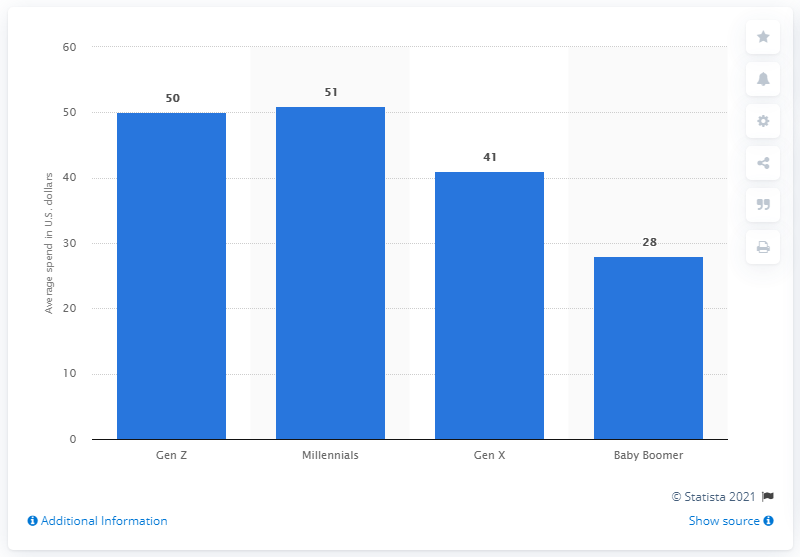How many dollars did Millennials plan to spend on their pets on average during the holiday season? Based on the bar chart, Millennials planned to spend an average of $51 on their pets during the holiday season. This amount was slightly more than Gen Z's average of $50, and noticeably higher than Gen X's $41 and Baby Boomers' $28, indicating that Millennials were particularly generous towards their pets during this festive time. 